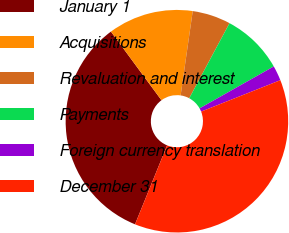<chart> <loc_0><loc_0><loc_500><loc_500><pie_chart><fcel>January 1<fcel>Acquisitions<fcel>Revaluation and interest<fcel>Payments<fcel>Foreign currency translation<fcel>December 31<nl><fcel>33.76%<fcel>12.37%<fcel>5.57%<fcel>8.97%<fcel>2.18%<fcel>37.15%<nl></chart> 